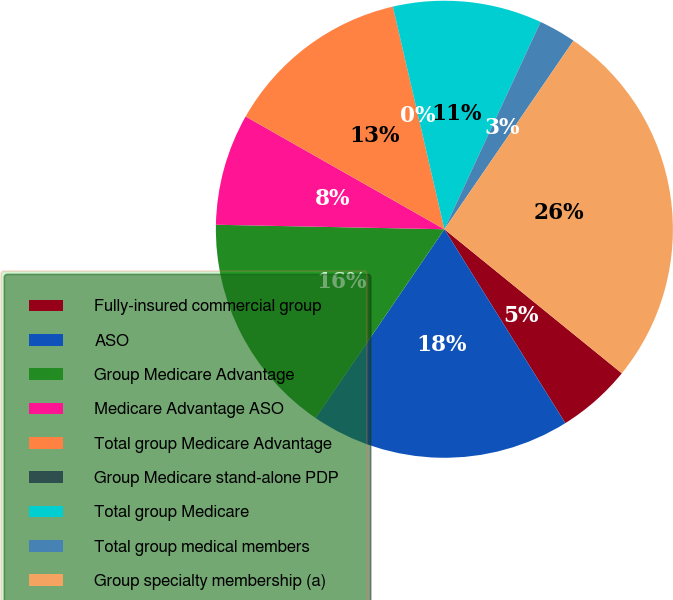<chart> <loc_0><loc_0><loc_500><loc_500><pie_chart><fcel>Fully-insured commercial group<fcel>ASO<fcel>Group Medicare Advantage<fcel>Medicare Advantage ASO<fcel>Total group Medicare Advantage<fcel>Group Medicare stand-alone PDP<fcel>Total group Medicare<fcel>Total group medical members<fcel>Group specialty membership (a)<nl><fcel>5.27%<fcel>18.41%<fcel>15.78%<fcel>7.9%<fcel>13.16%<fcel>0.01%<fcel>10.53%<fcel>2.64%<fcel>26.3%<nl></chart> 